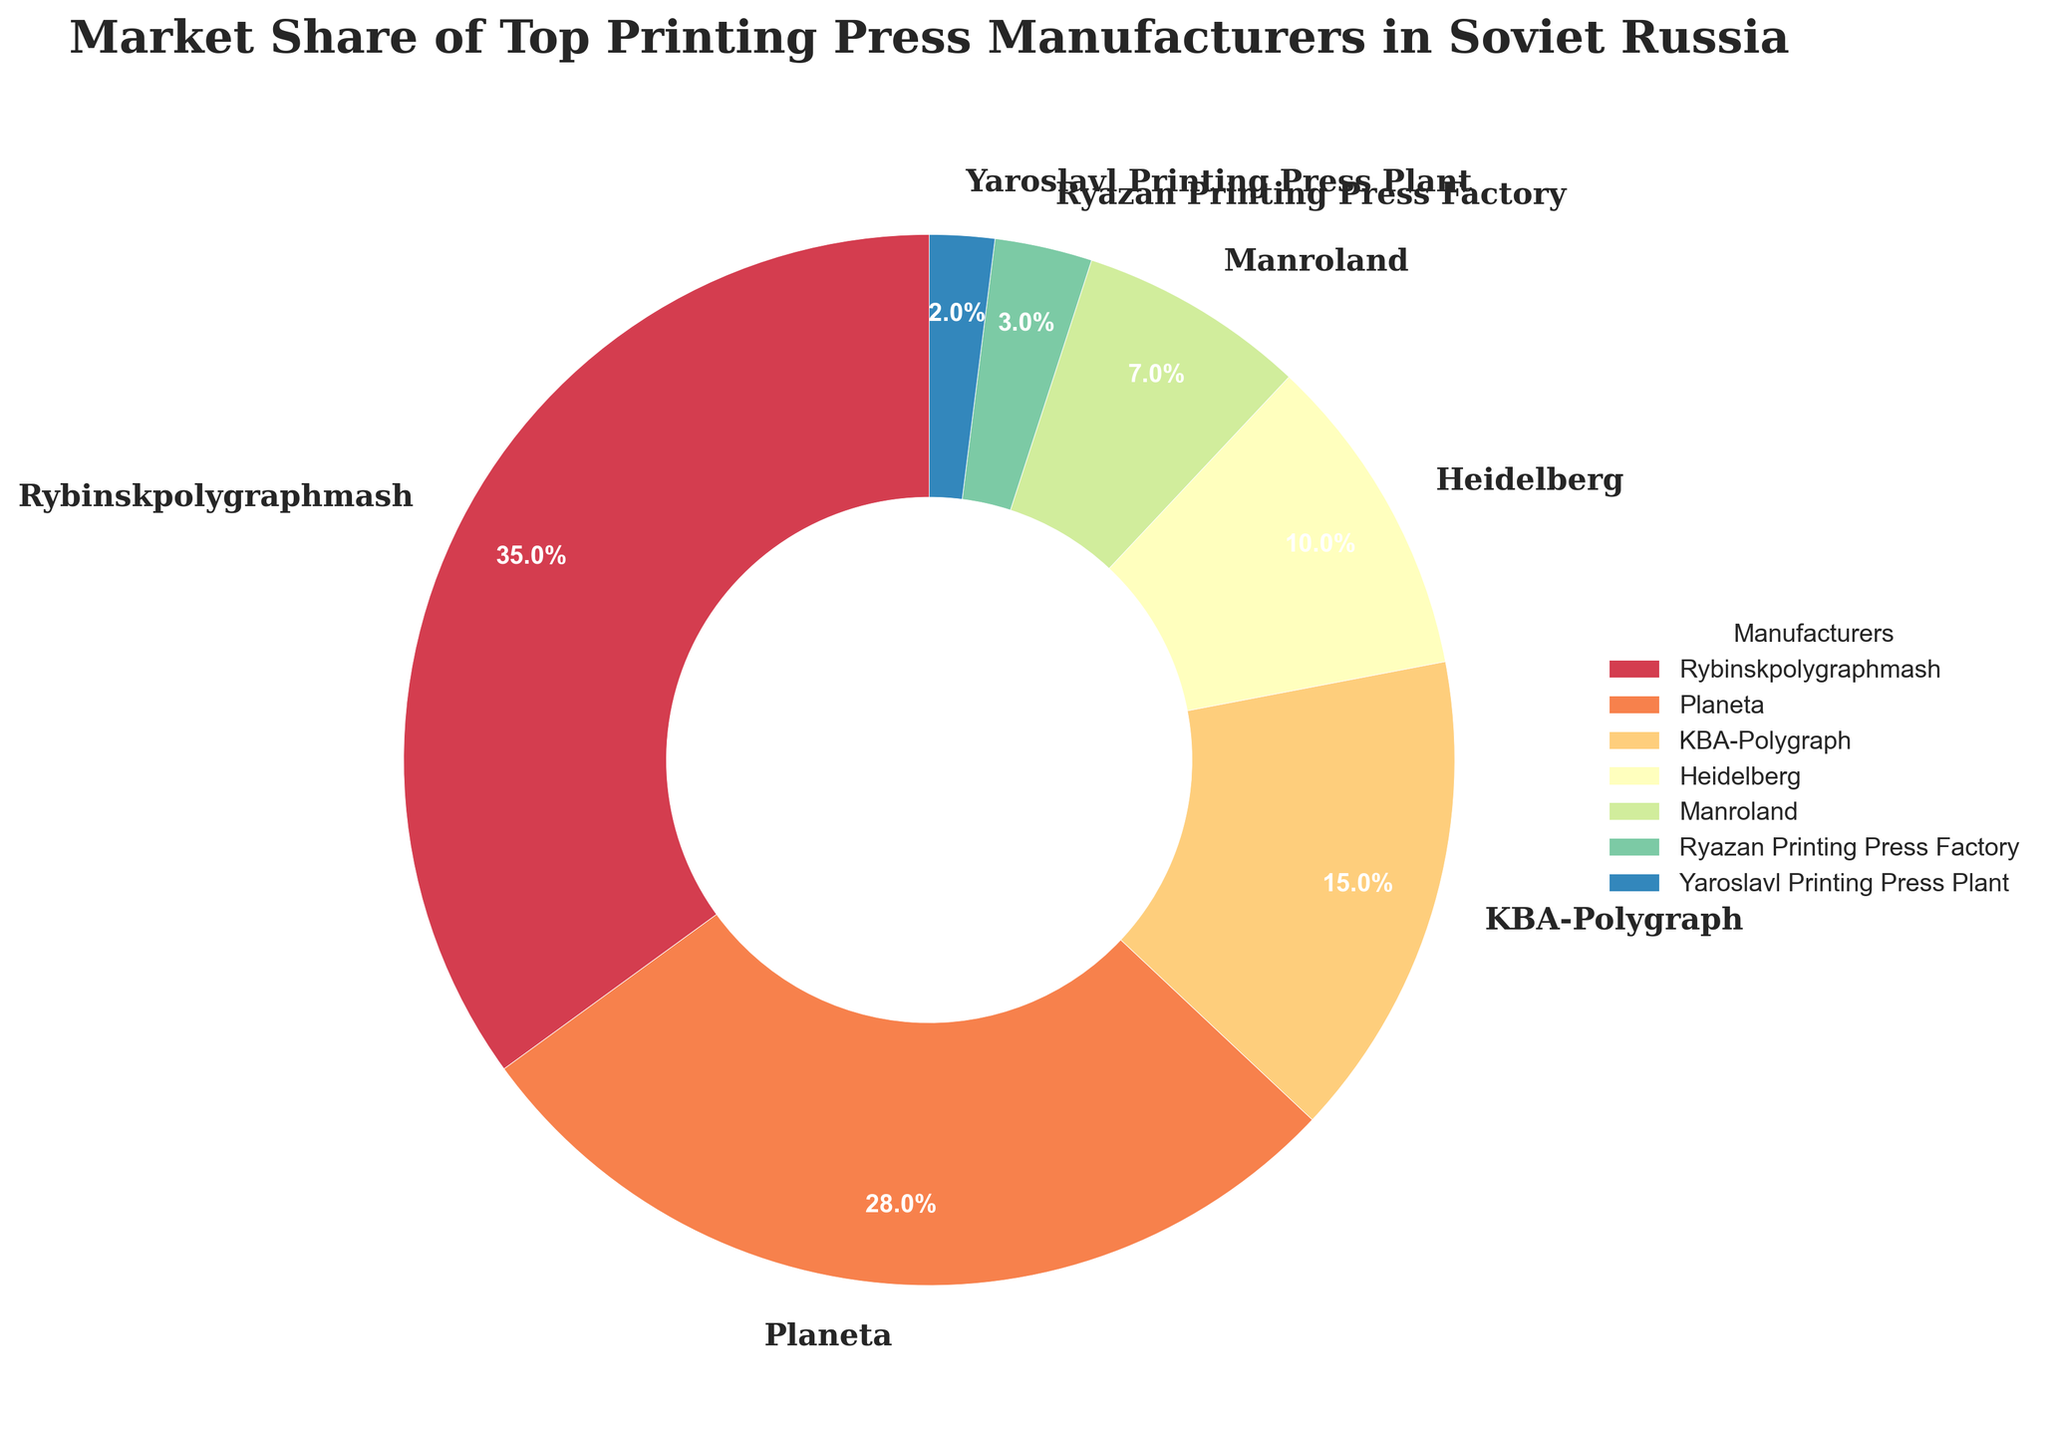What percentage of the market share did Rybinskpolygraphmash hold? Rybinskpolygraphmash had a market share of 35% as shown in the pie chart.
Answer: 35% How much more market share did Planeta have compared to Heidelberg? Planeta had a market share of 28%, while Heidelberg had a 10% share. Subtract Heidelberg's share from Planeta's: 28% - 10% = 18%
Answer: 18% What is the combined market share of Manroland and Ryazan Printing Press Factory? Manroland had a 7% share and Ryazan Printing Press Factory had a 3% share. Add them together: 7% + 3% = 10%
Answer: 10% Which manufacturer had the smallest market share, and what was it? Yaroslavl Printing Press Plant had the smallest market share of 2%, as shown in the pie chart.
Answer: Yaroslavl Printing Press Plant, 2% How many manufacturers had a market share greater than 10%? The manufacturers with a market share greater than 10% are Rybinskpolygraphmash (35%), Planeta (28%), and KBA-Polygraph (15%). This makes three manufacturers.
Answer: 3 Which two manufacturers combined would equal or slightly surpass Planeta's market share? To match or surpass Planeta's 28% market share, the combined shares of KBA-Polygraph (15%) and Heidelberg (10%) add up to 25%, so also consider Manroland (7%) and Heidelberg (10%) which add up to 17%; thus combining KBA-Polygraph and Heidelberg’s shares matches 25%. Finally, KBA-Polygraph and Manroland together surpass Planeta's market share with 15% + 7% = 22%.
Answer: KBA-Polygraph and Heidelberg or KBA-Polygraph and Manroland What percentage of the market is held by manufacturers other than the top three? The top three manufacturers are Rybinskpolygraphmash (35%), Planeta (28%), and KBA-Polygraph (15%) making a total of 78%. Subtracting from 100%: 100% - 78% = 22% of the market is held by the other manufacturers.
Answer: 22% How did the market share of Manroland compare visually to Ryazan Printing Press Factory? Visually, Manroland's segment is larger than the Ryazan Printing Press Factory's segment in the pie chart.
Answer: Manroland is larger 